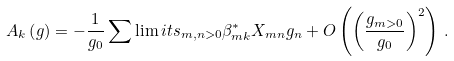<formula> <loc_0><loc_0><loc_500><loc_500>A _ { k } \left ( g \right ) = - \frac { 1 } { g _ { 0 } } \sum \lim i t s _ { m , n > 0 } \beta _ { m k } ^ { \ast } X _ { m n } g _ { n } + O \left ( \left ( \frac { g _ { m > 0 } } { g _ { 0 } } \right ) ^ { 2 } \right ) \, .</formula> 